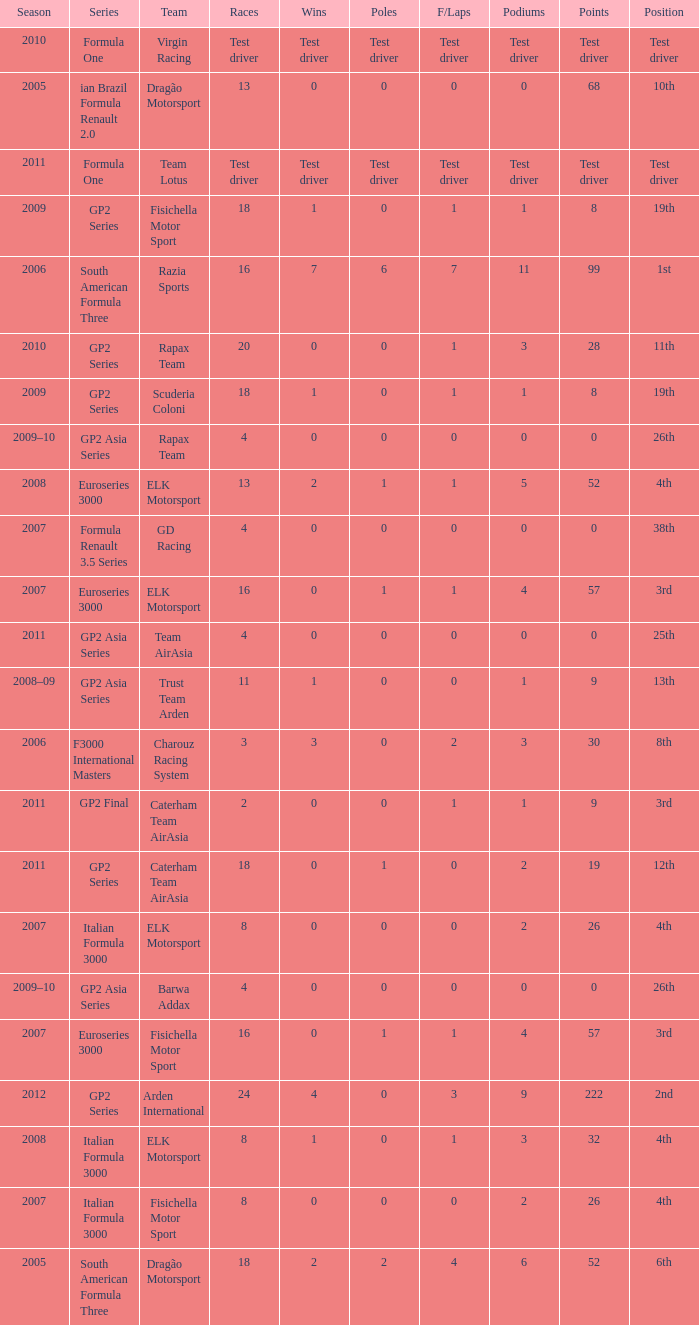What were the points in the year when his Wins were 0, his Podiums were 0, and he drove in 4 races? 0, 0, 0, 0. 